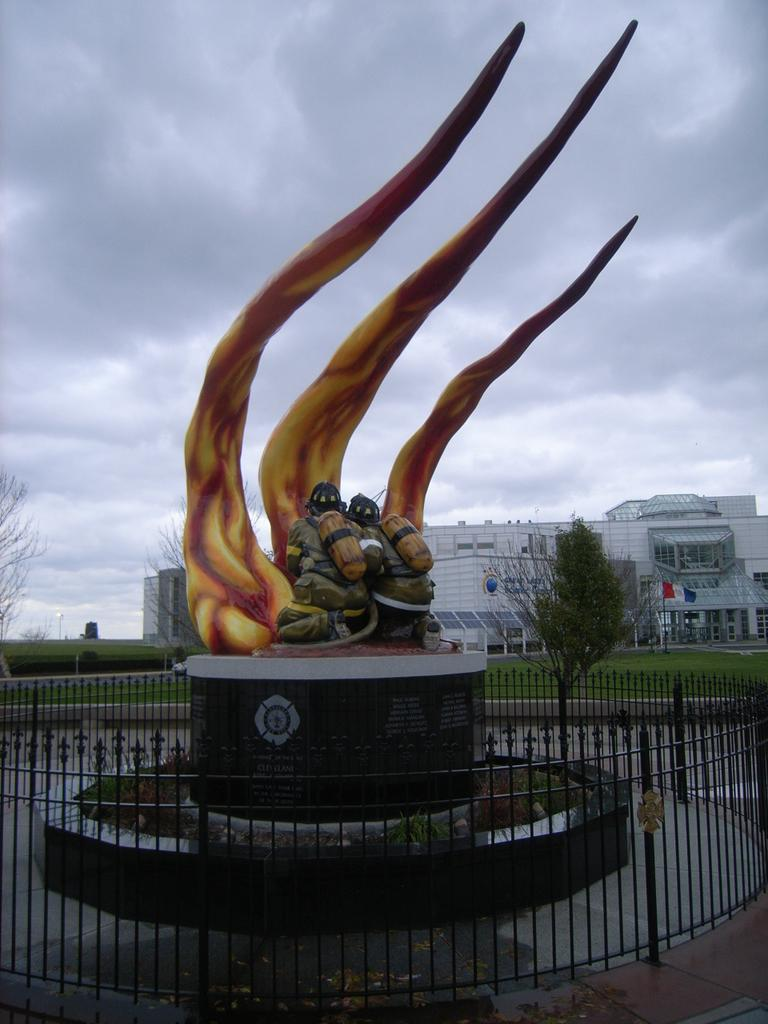What is the main subject in the image? There is a statue in the image. What surrounds the statue? There are iron grilles around the statue. What can be seen behind the statue? There are trees behind the statue. What is the flag's location in the image? The flag is visible in the image. What type of vegetation is present in the image? Grass is present in the image. What can be seen in the background of the image? There are buildings in the background. How would you describe the sky in the image? The sky is cloudy in the image. What color is the father's sock in the image? There is no father or sock present in the image. 